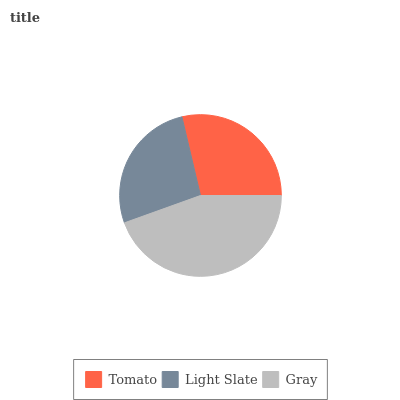Is Light Slate the minimum?
Answer yes or no. Yes. Is Gray the maximum?
Answer yes or no. Yes. Is Gray the minimum?
Answer yes or no. No. Is Light Slate the maximum?
Answer yes or no. No. Is Gray greater than Light Slate?
Answer yes or no. Yes. Is Light Slate less than Gray?
Answer yes or no. Yes. Is Light Slate greater than Gray?
Answer yes or no. No. Is Gray less than Light Slate?
Answer yes or no. No. Is Tomato the high median?
Answer yes or no. Yes. Is Tomato the low median?
Answer yes or no. Yes. Is Gray the high median?
Answer yes or no. No. Is Gray the low median?
Answer yes or no. No. 